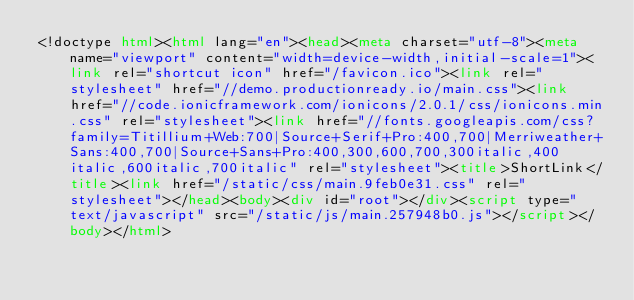<code> <loc_0><loc_0><loc_500><loc_500><_HTML_><!doctype html><html lang="en"><head><meta charset="utf-8"><meta name="viewport" content="width=device-width,initial-scale=1"><link rel="shortcut icon" href="/favicon.ico"><link rel="stylesheet" href="//demo.productionready.io/main.css"><link href="//code.ionicframework.com/ionicons/2.0.1/css/ionicons.min.css" rel="stylesheet"><link href="//fonts.googleapis.com/css?family=Titillium+Web:700|Source+Serif+Pro:400,700|Merriweather+Sans:400,700|Source+Sans+Pro:400,300,600,700,300italic,400italic,600italic,700italic" rel="stylesheet"><title>ShortLink</title><link href="/static/css/main.9feb0e31.css" rel="stylesheet"></head><body><div id="root"></div><script type="text/javascript" src="/static/js/main.257948b0.js"></script></body></html></code> 